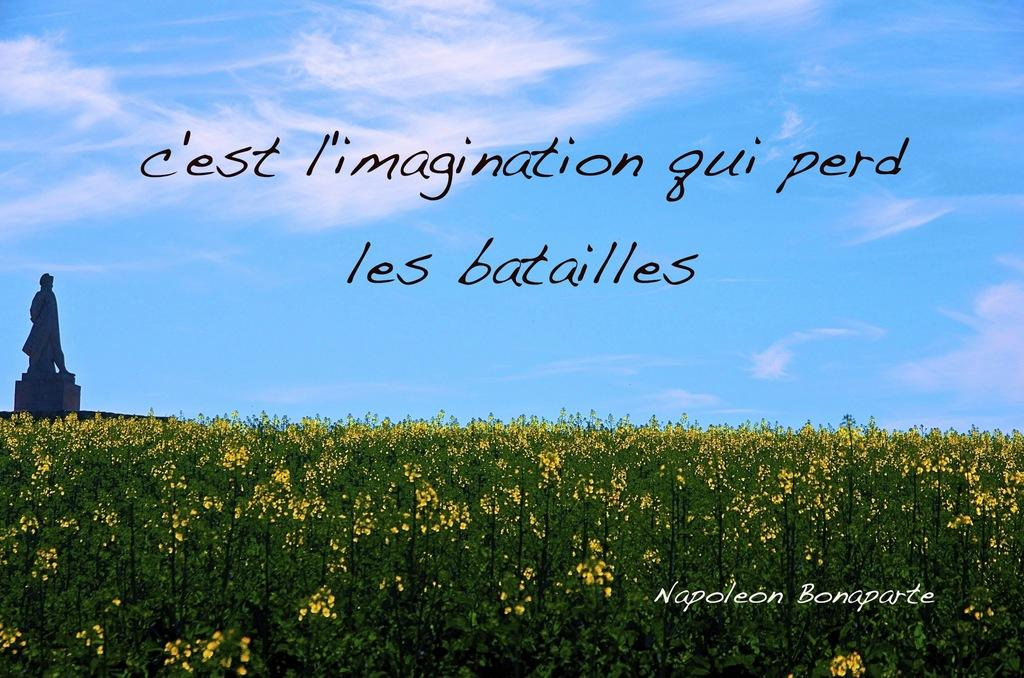What type of visual is the image? The image is a poster. What can be found on the poster besides visual elements? There is text on the poster. What type of natural elements are present in the image? There are plants in the image. What can be seen in the background of the image? The sky with clouds is visible in the background. Where is the statue located in the image? The statue is on a pedestal on the left side of the image. Reasoning: Let's think step by step by step in order to produce the conversation. We start by identifying the type of visual, which is a poster. Then, we describe the content of the poster, including the presence of text and visual elements. Next, we mention the natural elements present in the image, such as plants. We then focus on the background, which features the sky with clouds. Finally, we locate the statue and its position on a pedestal on the left side of the image. Absurd Question/Answer: How many markets are visible in the image? There are no markets present in the image. What type of creature can be seen interacting with the earth in the image? There is no creature interacting with the earth in the image. 